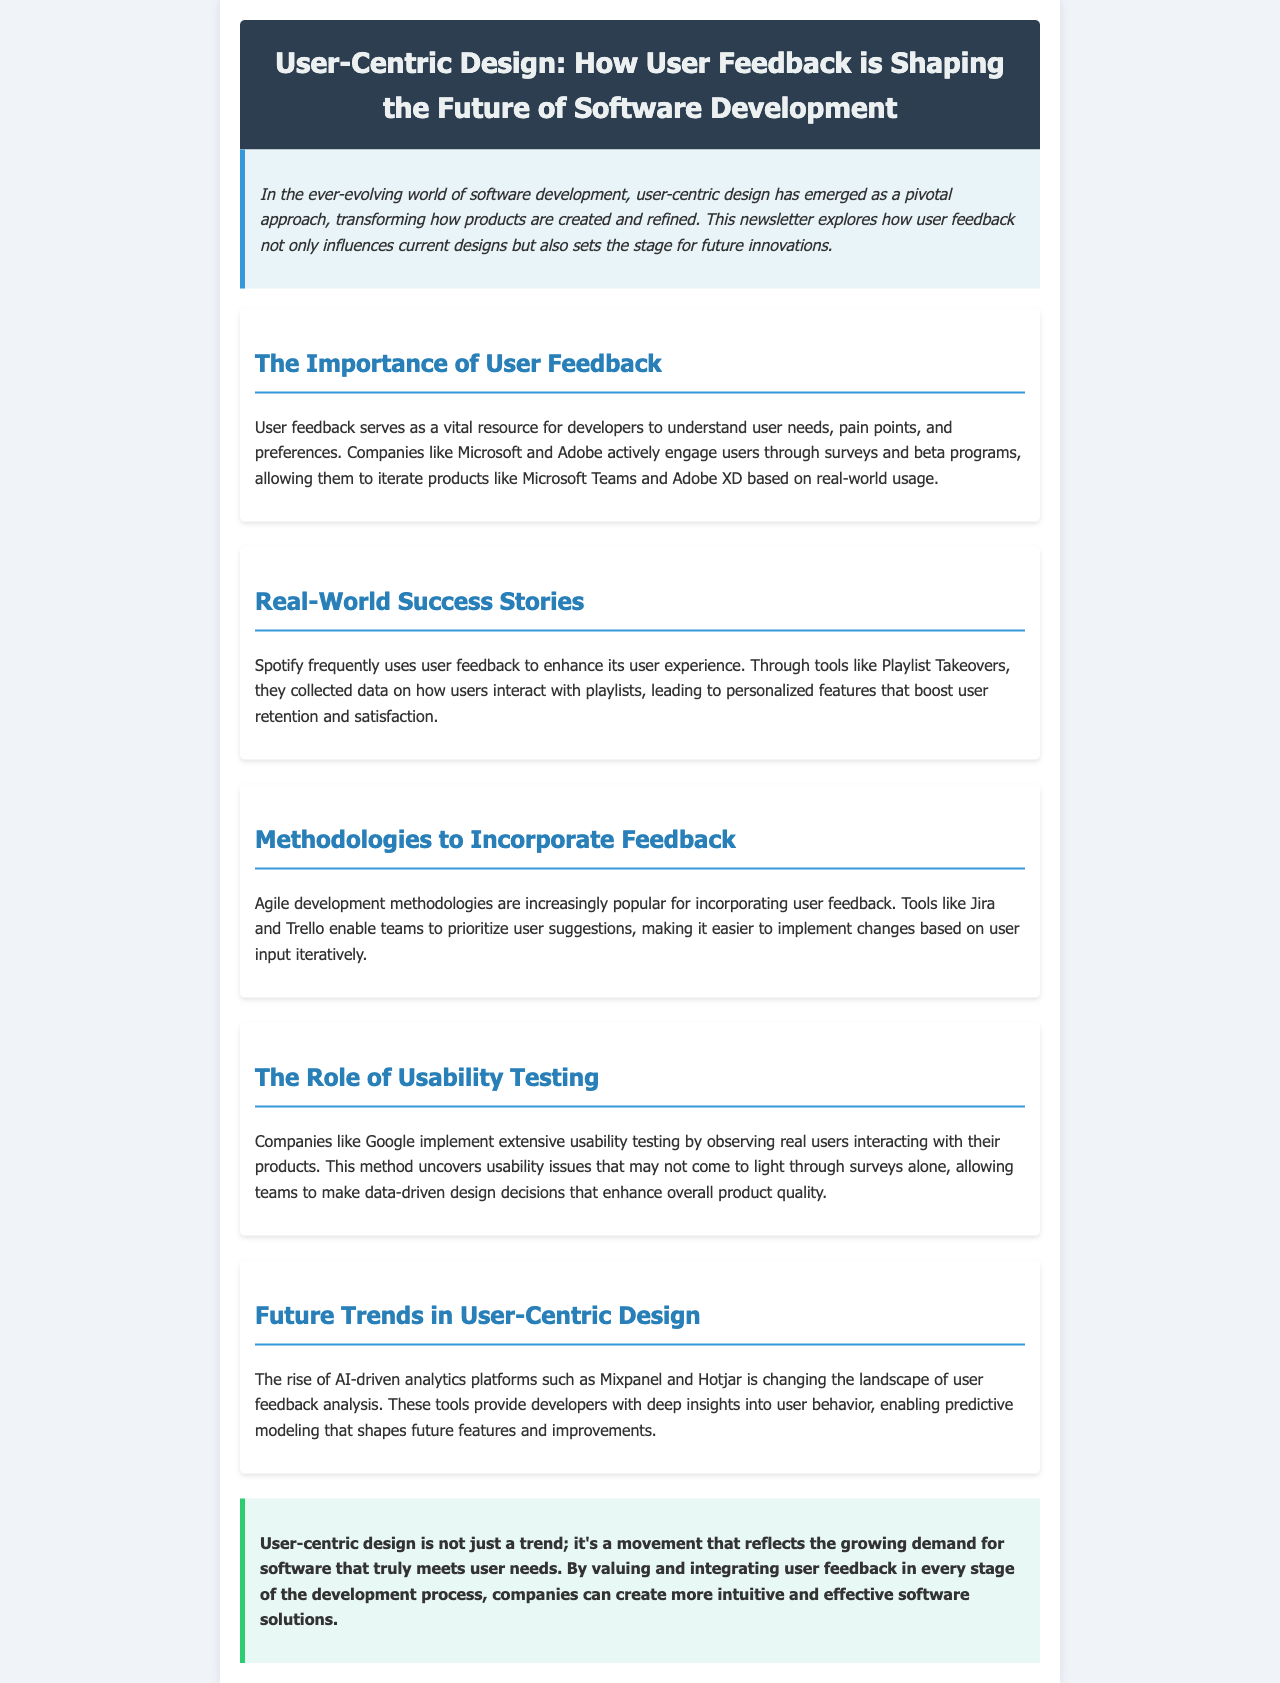What is the main topic of the newsletter? The main topic is indicated in the title of the newsletter.
Answer: User-Centric Design Which companies are mentioned as actively engaging users through feedback? The document specifically names companies that utilize user feedback in their software development processes.
Answer: Microsoft and Adobe What methodology is becoming popular for incorporating user feedback? The section discusses methodologies that facilitate user feedback integration.
Answer: Agile development Which tool does Spotify use to enhance user experience? This question refers to a specific feature mentioned in the successes of using user feedback.
Answer: Playlist Takeovers What is the role of usability testing according to the document? The document explains how usability testing contributes to product development.
Answer: Uncovers usability issues What future trend is mentioned regarding user feedback analysis? The section highlights advancements in technology for analyzing user feedback.
Answer: AI-driven analytics platforms How does Google approach usability testing? This question looks for a specific approach taken by Google as detailed in the newsletter.
Answer: Observing real users What is the concluding sentiment about user-centric design? The conclusion wraps up the discussion with a specific sentiment about the trend.
Answer: A movement 